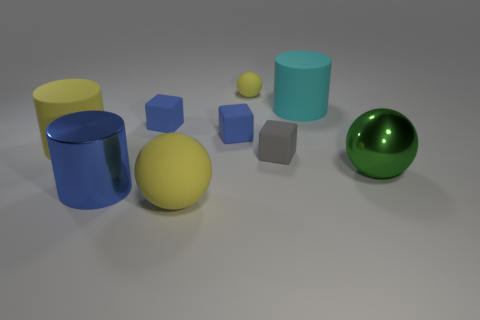Is the number of cyan spheres less than the number of yellow cylinders?
Ensure brevity in your answer.  Yes. There is a big rubber cylinder that is on the right side of the block that is left of the large yellow rubber sphere; is there a large object to the right of it?
Your response must be concise. Yes. Is the shape of the large metallic object that is on the right side of the big cyan object the same as  the small yellow matte object?
Your response must be concise. Yes. Is the number of big yellow rubber balls behind the gray matte block greater than the number of rubber cylinders?
Ensure brevity in your answer.  No. There is a large ball that is in front of the large metallic ball; is its color the same as the large metal ball?
Make the answer very short. No. Are there any other things of the same color as the metallic sphere?
Keep it short and to the point. No. There is a rubber object that is on the left side of the blue block that is left of the large ball that is on the left side of the gray thing; what is its color?
Your answer should be very brief. Yellow. Is the cyan object the same size as the blue cylinder?
Make the answer very short. Yes. How many blue cylinders are the same size as the green object?
Your answer should be very brief. 1. The small thing that is the same color as the large rubber sphere is what shape?
Provide a succinct answer. Sphere. 